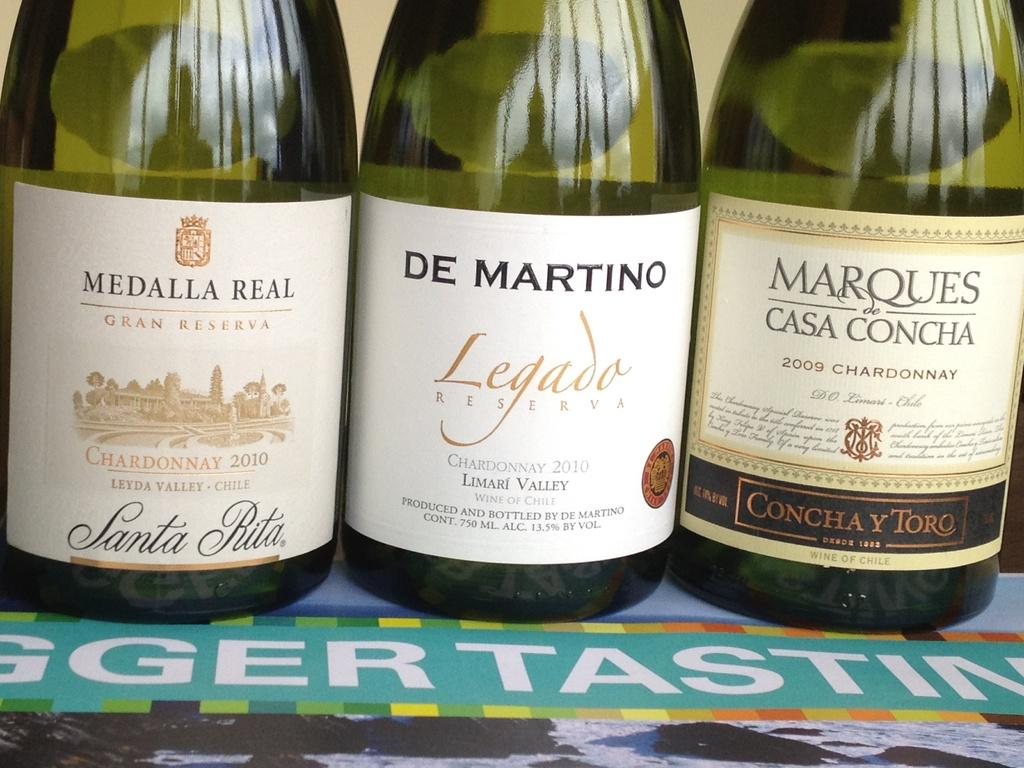How many wine bottles are visible in the image? There are three wine bottles in the image. Where are the wine bottles located? The wine bottles are on a table. Can you describe the labels on the wine bottles? Each wine bottle has a different label. What can be seen in the background of the image? There is a wall in the background of the image. What muscle is being exercised by the wine bottles in the image? Wine bottles do not have muscles, so this question cannot be answered. 